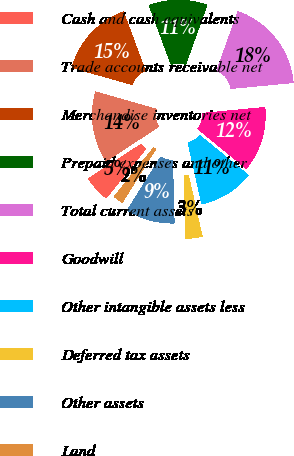Convert chart to OTSL. <chart><loc_0><loc_0><loc_500><loc_500><pie_chart><fcel>Cash and cash equivalents<fcel>Trade accounts receivable net<fcel>Merchandise inventories net<fcel>Prepaid expenses and other<fcel>Total current assets<fcel>Goodwill<fcel>Other intangible assets less<fcel>Deferred tax assets<fcel>Other assets<fcel>Land<nl><fcel>4.98%<fcel>13.66%<fcel>14.9%<fcel>11.18%<fcel>18.0%<fcel>12.42%<fcel>10.56%<fcel>3.12%<fcel>9.32%<fcel>1.87%<nl></chart> 